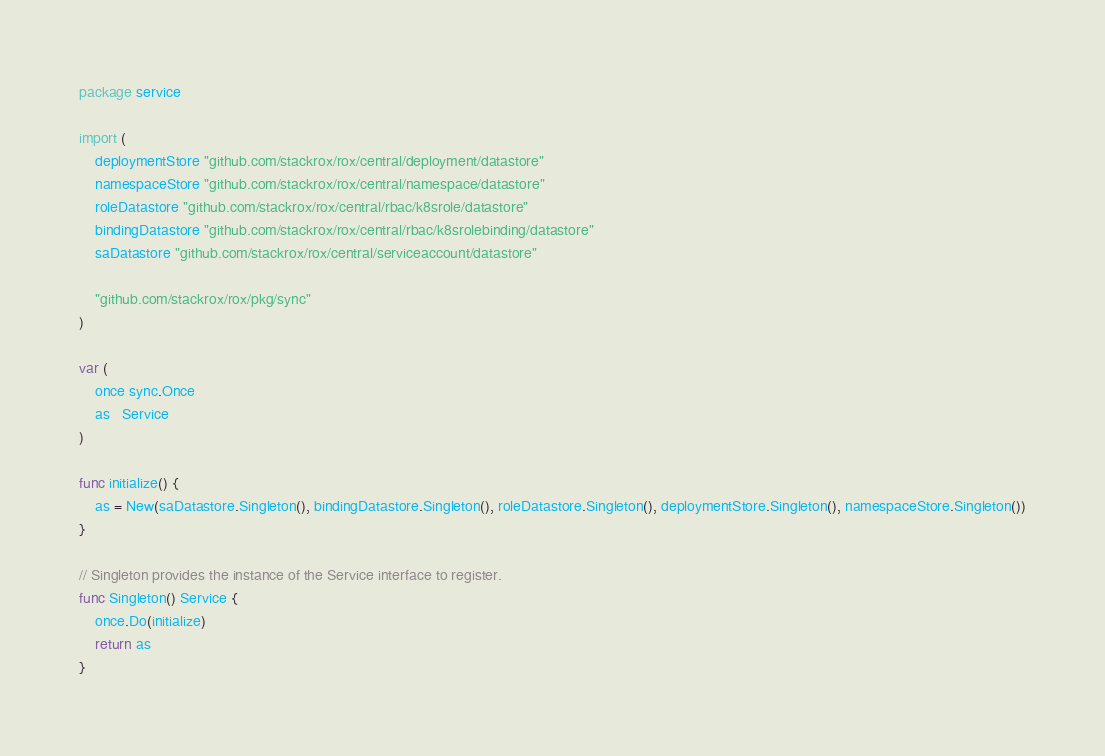Convert code to text. <code><loc_0><loc_0><loc_500><loc_500><_Go_>package service

import (
	deploymentStore "github.com/stackrox/rox/central/deployment/datastore"
	namespaceStore "github.com/stackrox/rox/central/namespace/datastore"
	roleDatastore "github.com/stackrox/rox/central/rbac/k8srole/datastore"
	bindingDatastore "github.com/stackrox/rox/central/rbac/k8srolebinding/datastore"
	saDatastore "github.com/stackrox/rox/central/serviceaccount/datastore"

	"github.com/stackrox/rox/pkg/sync"
)

var (
	once sync.Once
	as   Service
)

func initialize() {
	as = New(saDatastore.Singleton(), bindingDatastore.Singleton(), roleDatastore.Singleton(), deploymentStore.Singleton(), namespaceStore.Singleton())
}

// Singleton provides the instance of the Service interface to register.
func Singleton() Service {
	once.Do(initialize)
	return as
}
</code> 